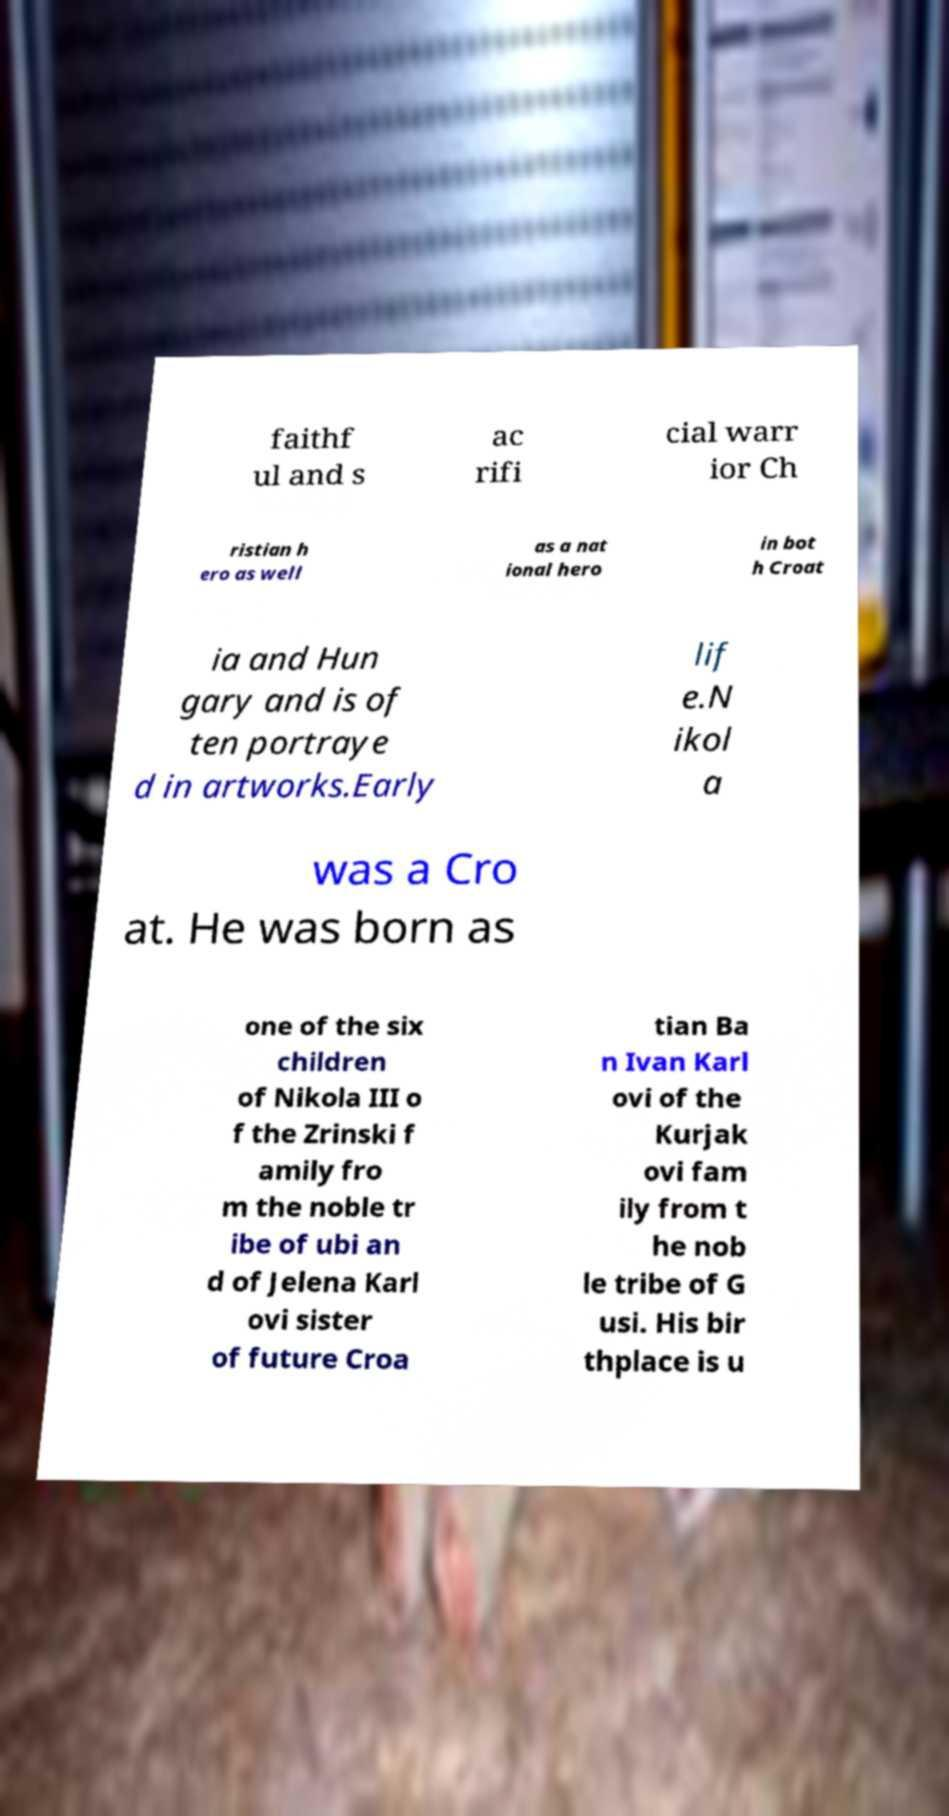Please read and relay the text visible in this image. What does it say? faithf ul and s ac rifi cial warr ior Ch ristian h ero as well as a nat ional hero in bot h Croat ia and Hun gary and is of ten portraye d in artworks.Early lif e.N ikol a was a Cro at. He was born as one of the six children of Nikola III o f the Zrinski f amily fro m the noble tr ibe of ubi an d of Jelena Karl ovi sister of future Croa tian Ba n Ivan Karl ovi of the Kurjak ovi fam ily from t he nob le tribe of G usi. His bir thplace is u 